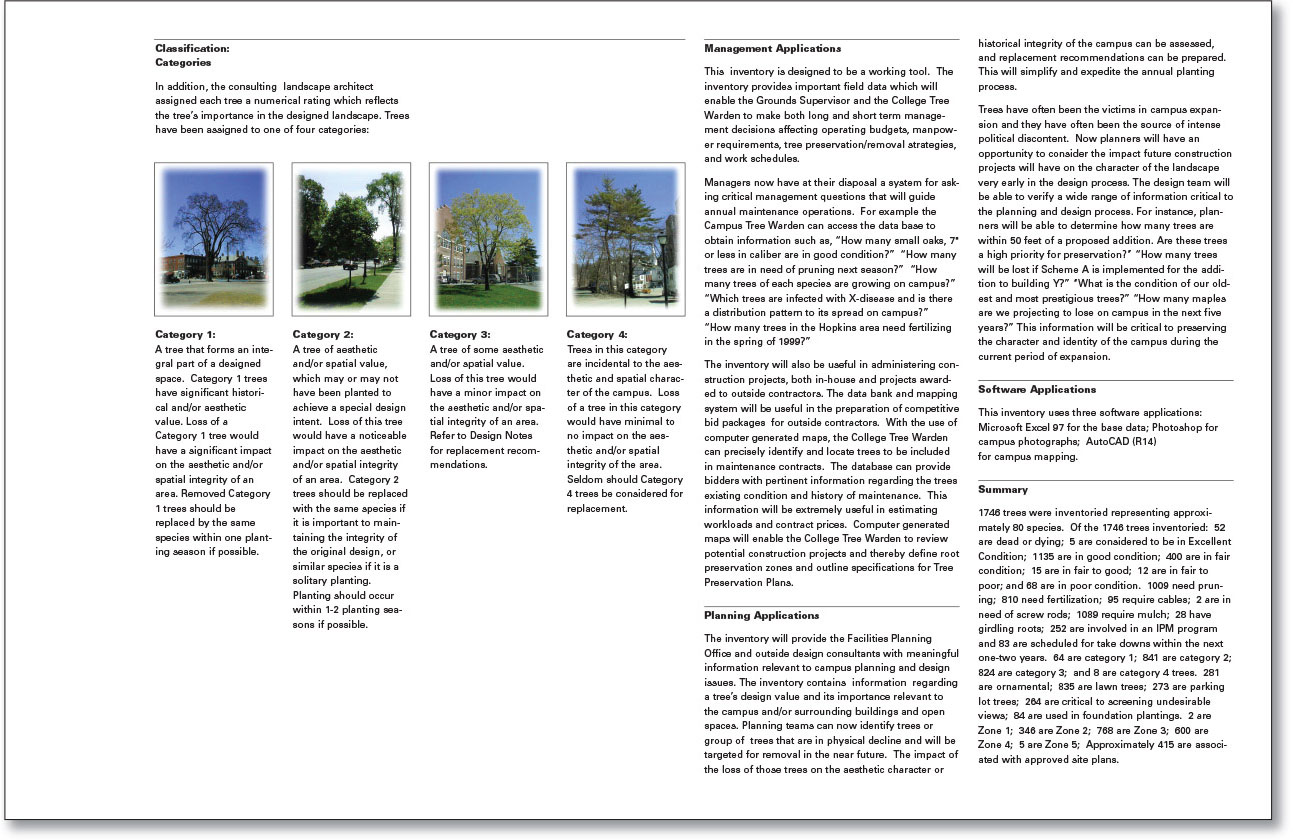How might the removal of Category 1 trees impact the campus's historical integrity? Category 1 trees are integral to the designed spaces they inhabit, often holding significant historical and aesthetic value. Their removal would have a substantial impact on the campus's historical integrity, as these trees contribute to the visual and spatial character of specific areas. Removing such trees would require careful consideration and likely necessitate the replacement with the sharegpt4v/same species within the planting season, to maintain the designed landscape and historical context. 